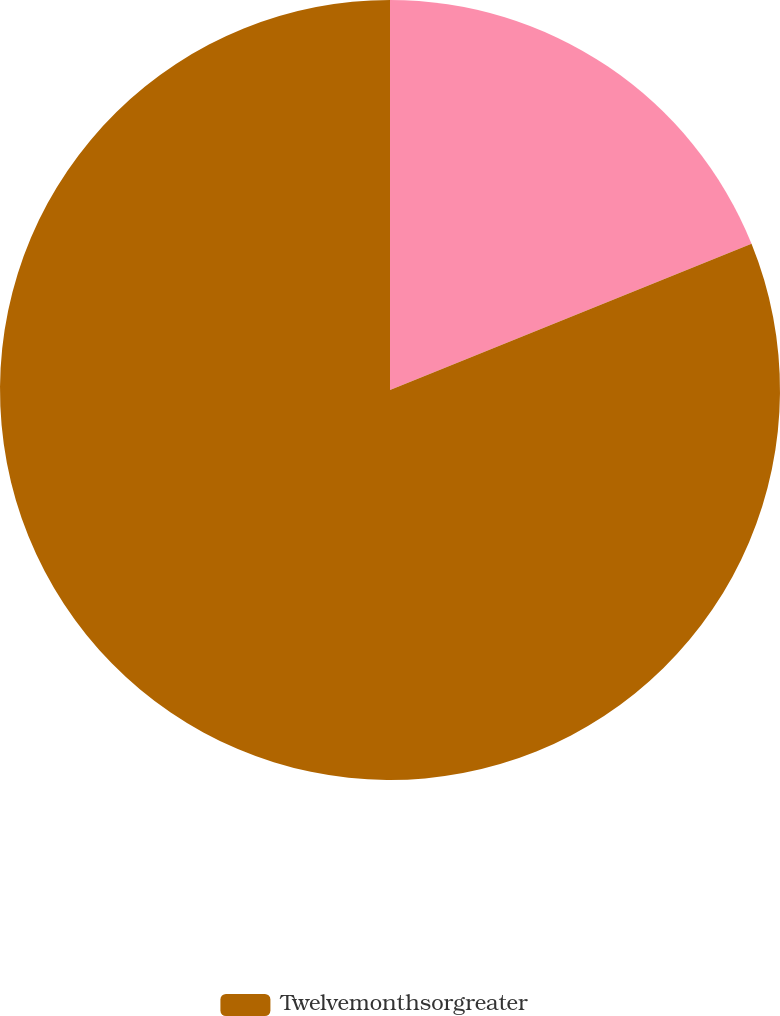Convert chart to OTSL. <chart><loc_0><loc_0><loc_500><loc_500><pie_chart><ecel><fcel>Twelvemonthsorgreater<nl><fcel>18.88%<fcel>81.12%<nl></chart> 